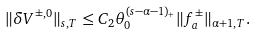Convert formula to latex. <formula><loc_0><loc_0><loc_500><loc_500>\| \delta V ^ { \pm , 0 } \| _ { s , T } \leq C _ { 2 } \theta _ { 0 } ^ { ( s - \alpha - 1 ) _ { + } } \| f _ { a } ^ { \pm } \| _ { \alpha + 1 , T } .</formula> 